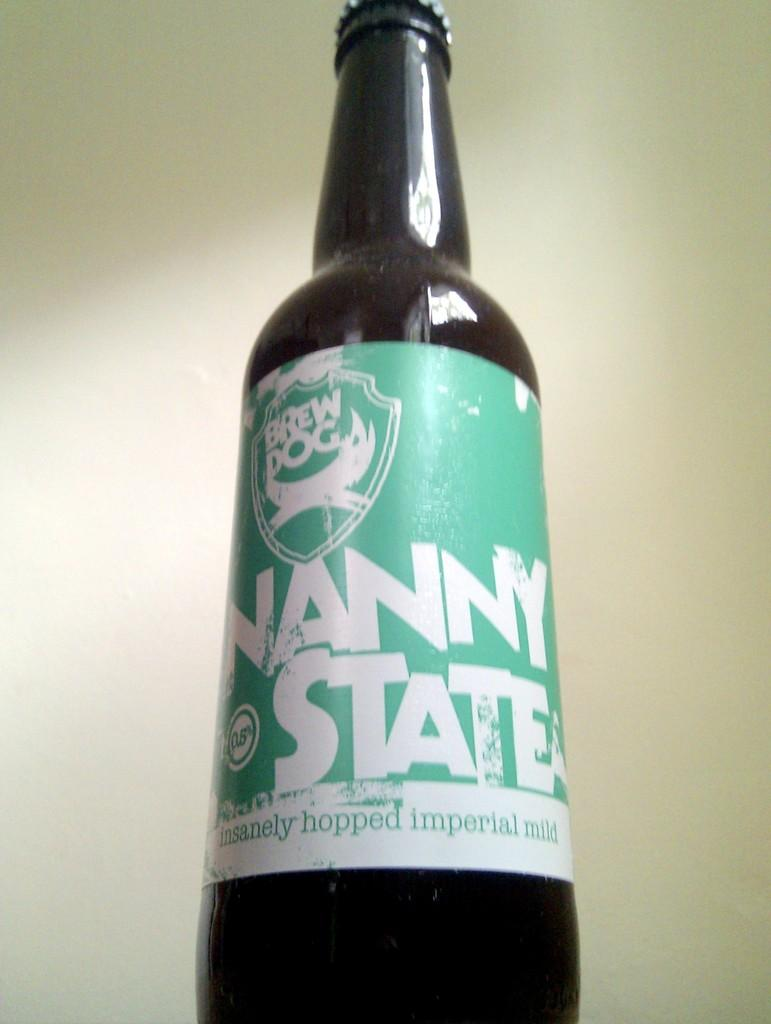Provide a one-sentence caption for the provided image. A closed bottle of Nanny state beer from brew dog. 